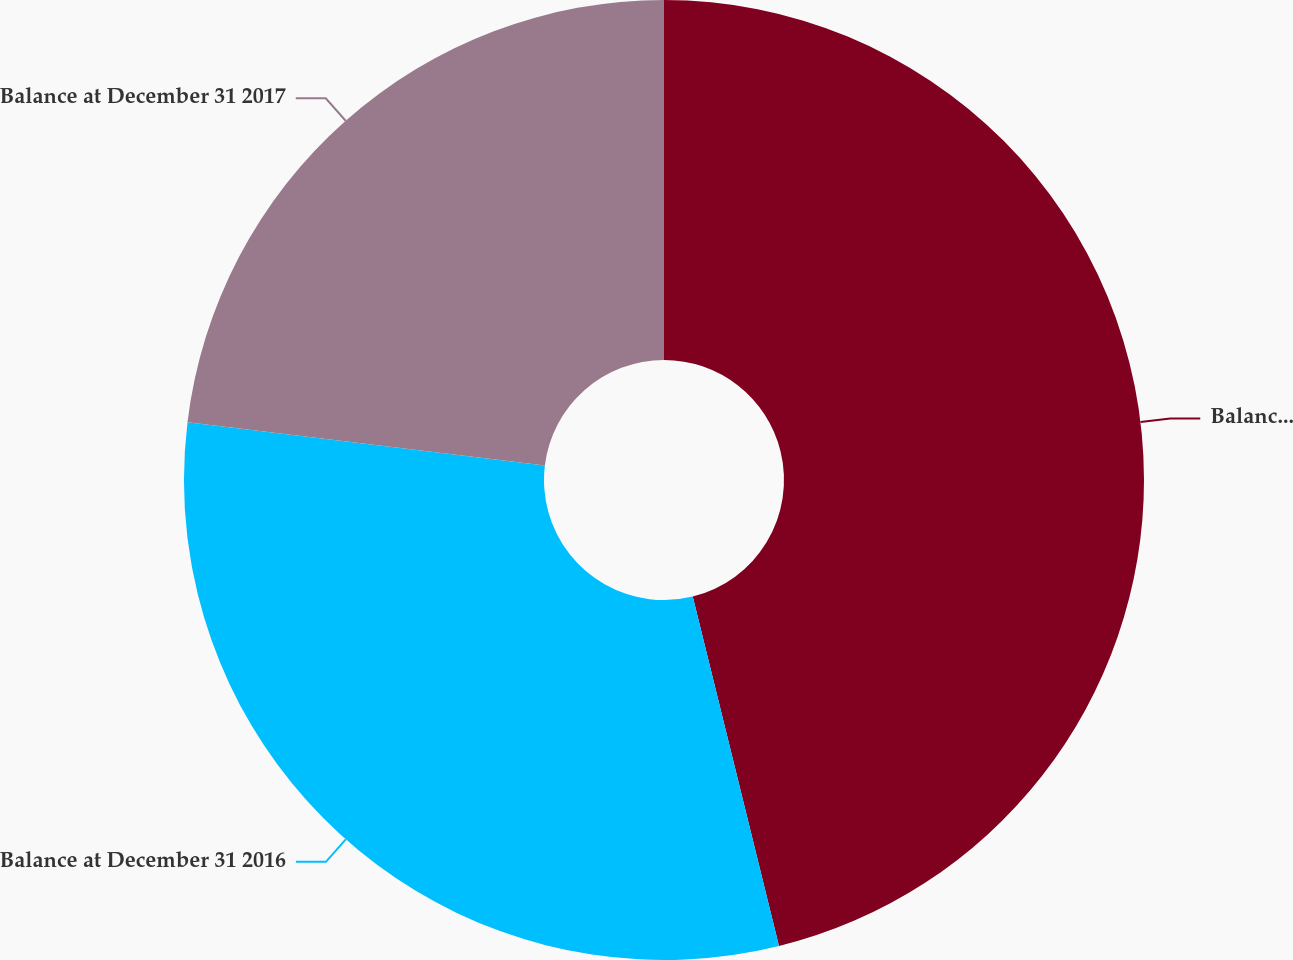Convert chart to OTSL. <chart><loc_0><loc_0><loc_500><loc_500><pie_chart><fcel>Balance at January 1 2016<fcel>Balance at December 31 2016<fcel>Balance at December 31 2017<nl><fcel>46.15%<fcel>30.77%<fcel>23.08%<nl></chart> 